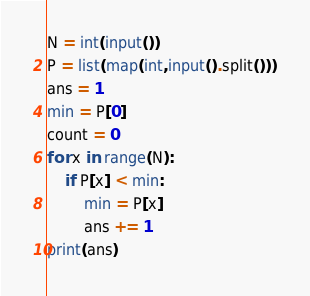<code> <loc_0><loc_0><loc_500><loc_500><_Python_>N = int(input())
P = list(map(int,input().split()))
ans = 1
min = P[0]
count = 0
for x in range(N):
    if P[x] < min:
        min = P[x]
        ans += 1
print(ans)</code> 